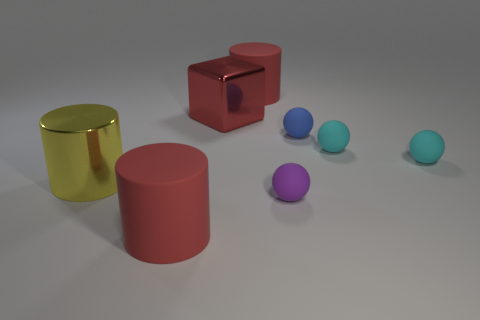Which shapes in the image seem to be perfect geometric solids? The red cube and both cylinders (one red and one golden yellow) are perfect geometric solids. The balls also represent spheres which are geometric solids. 